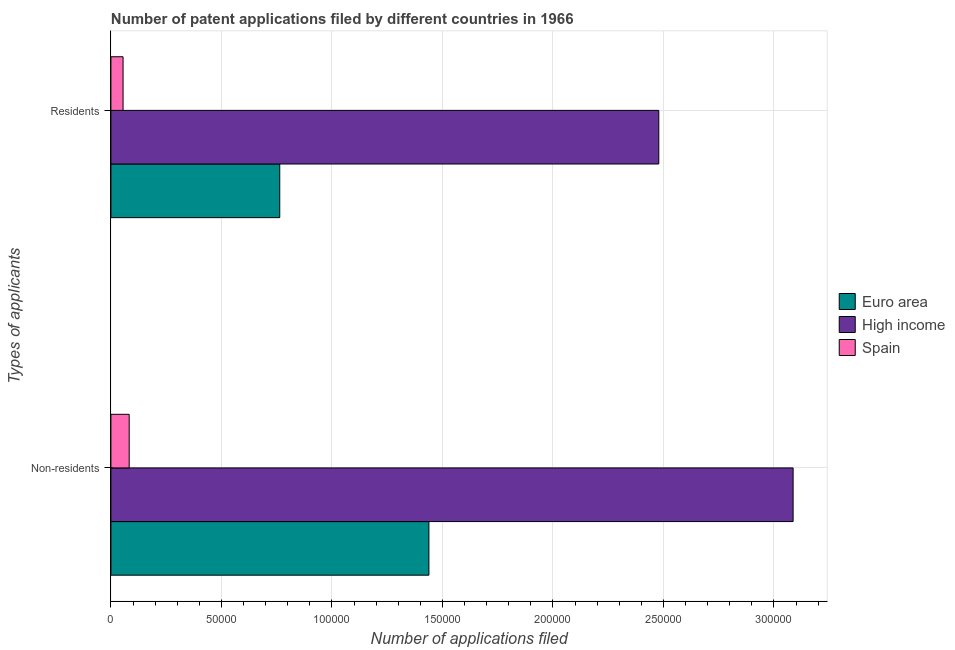How many groups of bars are there?
Provide a succinct answer. 2. Are the number of bars per tick equal to the number of legend labels?
Give a very brief answer. Yes. What is the label of the 1st group of bars from the top?
Keep it short and to the point. Residents. What is the number of patent applications by residents in Spain?
Offer a terse response. 5500. Across all countries, what is the maximum number of patent applications by residents?
Provide a short and direct response. 2.48e+05. Across all countries, what is the minimum number of patent applications by residents?
Offer a terse response. 5500. In which country was the number of patent applications by non residents maximum?
Keep it short and to the point. High income. In which country was the number of patent applications by residents minimum?
Your answer should be very brief. Spain. What is the total number of patent applications by residents in the graph?
Your answer should be very brief. 3.30e+05. What is the difference between the number of patent applications by residents in High income and that in Euro area?
Ensure brevity in your answer.  1.72e+05. What is the difference between the number of patent applications by residents in Euro area and the number of patent applications by non residents in High income?
Provide a short and direct response. -2.32e+05. What is the average number of patent applications by residents per country?
Give a very brief answer. 1.10e+05. What is the difference between the number of patent applications by non residents and number of patent applications by residents in High income?
Provide a succinct answer. 6.08e+04. What is the ratio of the number of patent applications by non residents in Euro area to that in High income?
Your response must be concise. 0.47. In how many countries, is the number of patent applications by residents greater than the average number of patent applications by residents taken over all countries?
Make the answer very short. 1. What does the 3rd bar from the top in Residents represents?
Your answer should be very brief. Euro area. What does the 1st bar from the bottom in Residents represents?
Your response must be concise. Euro area. How many bars are there?
Your response must be concise. 6. Are all the bars in the graph horizontal?
Your answer should be very brief. Yes. How many countries are there in the graph?
Your response must be concise. 3. Does the graph contain grids?
Offer a very short reply. Yes. How are the legend labels stacked?
Provide a short and direct response. Vertical. What is the title of the graph?
Your answer should be compact. Number of patent applications filed by different countries in 1966. Does "Guinea" appear as one of the legend labels in the graph?
Provide a short and direct response. No. What is the label or title of the X-axis?
Your answer should be very brief. Number of applications filed. What is the label or title of the Y-axis?
Make the answer very short. Types of applicants. What is the Number of applications filed in Euro area in Non-residents?
Give a very brief answer. 1.44e+05. What is the Number of applications filed in High income in Non-residents?
Provide a succinct answer. 3.09e+05. What is the Number of applications filed of Spain in Non-residents?
Provide a succinct answer. 8266. What is the Number of applications filed in Euro area in Residents?
Provide a succinct answer. 7.64e+04. What is the Number of applications filed in High income in Residents?
Offer a very short reply. 2.48e+05. What is the Number of applications filed in Spain in Residents?
Ensure brevity in your answer.  5500. Across all Types of applicants, what is the maximum Number of applications filed of Euro area?
Keep it short and to the point. 1.44e+05. Across all Types of applicants, what is the maximum Number of applications filed in High income?
Your answer should be compact. 3.09e+05. Across all Types of applicants, what is the maximum Number of applications filed of Spain?
Offer a terse response. 8266. Across all Types of applicants, what is the minimum Number of applications filed in Euro area?
Provide a short and direct response. 7.64e+04. Across all Types of applicants, what is the minimum Number of applications filed in High income?
Offer a terse response. 2.48e+05. Across all Types of applicants, what is the minimum Number of applications filed in Spain?
Your answer should be compact. 5500. What is the total Number of applications filed in Euro area in the graph?
Your answer should be very brief. 2.20e+05. What is the total Number of applications filed of High income in the graph?
Offer a terse response. 5.57e+05. What is the total Number of applications filed in Spain in the graph?
Give a very brief answer. 1.38e+04. What is the difference between the Number of applications filed of Euro area in Non-residents and that in Residents?
Your answer should be compact. 6.75e+04. What is the difference between the Number of applications filed of High income in Non-residents and that in Residents?
Offer a very short reply. 6.08e+04. What is the difference between the Number of applications filed of Spain in Non-residents and that in Residents?
Your response must be concise. 2766. What is the difference between the Number of applications filed of Euro area in Non-residents and the Number of applications filed of High income in Residents?
Your answer should be compact. -1.04e+05. What is the difference between the Number of applications filed of Euro area in Non-residents and the Number of applications filed of Spain in Residents?
Give a very brief answer. 1.38e+05. What is the difference between the Number of applications filed of High income in Non-residents and the Number of applications filed of Spain in Residents?
Give a very brief answer. 3.03e+05. What is the average Number of applications filed in Euro area per Types of applicants?
Give a very brief answer. 1.10e+05. What is the average Number of applications filed in High income per Types of applicants?
Your response must be concise. 2.78e+05. What is the average Number of applications filed in Spain per Types of applicants?
Offer a very short reply. 6883. What is the difference between the Number of applications filed of Euro area and Number of applications filed of High income in Non-residents?
Make the answer very short. -1.65e+05. What is the difference between the Number of applications filed of Euro area and Number of applications filed of Spain in Non-residents?
Your answer should be very brief. 1.36e+05. What is the difference between the Number of applications filed of High income and Number of applications filed of Spain in Non-residents?
Give a very brief answer. 3.00e+05. What is the difference between the Number of applications filed in Euro area and Number of applications filed in High income in Residents?
Make the answer very short. -1.72e+05. What is the difference between the Number of applications filed of Euro area and Number of applications filed of Spain in Residents?
Your answer should be very brief. 7.09e+04. What is the difference between the Number of applications filed of High income and Number of applications filed of Spain in Residents?
Ensure brevity in your answer.  2.42e+05. What is the ratio of the Number of applications filed of Euro area in Non-residents to that in Residents?
Provide a short and direct response. 1.88. What is the ratio of the Number of applications filed in High income in Non-residents to that in Residents?
Provide a short and direct response. 1.25. What is the ratio of the Number of applications filed in Spain in Non-residents to that in Residents?
Your response must be concise. 1.5. What is the difference between the highest and the second highest Number of applications filed in Euro area?
Keep it short and to the point. 6.75e+04. What is the difference between the highest and the second highest Number of applications filed in High income?
Your response must be concise. 6.08e+04. What is the difference between the highest and the second highest Number of applications filed in Spain?
Offer a terse response. 2766. What is the difference between the highest and the lowest Number of applications filed of Euro area?
Your answer should be very brief. 6.75e+04. What is the difference between the highest and the lowest Number of applications filed in High income?
Provide a short and direct response. 6.08e+04. What is the difference between the highest and the lowest Number of applications filed of Spain?
Give a very brief answer. 2766. 